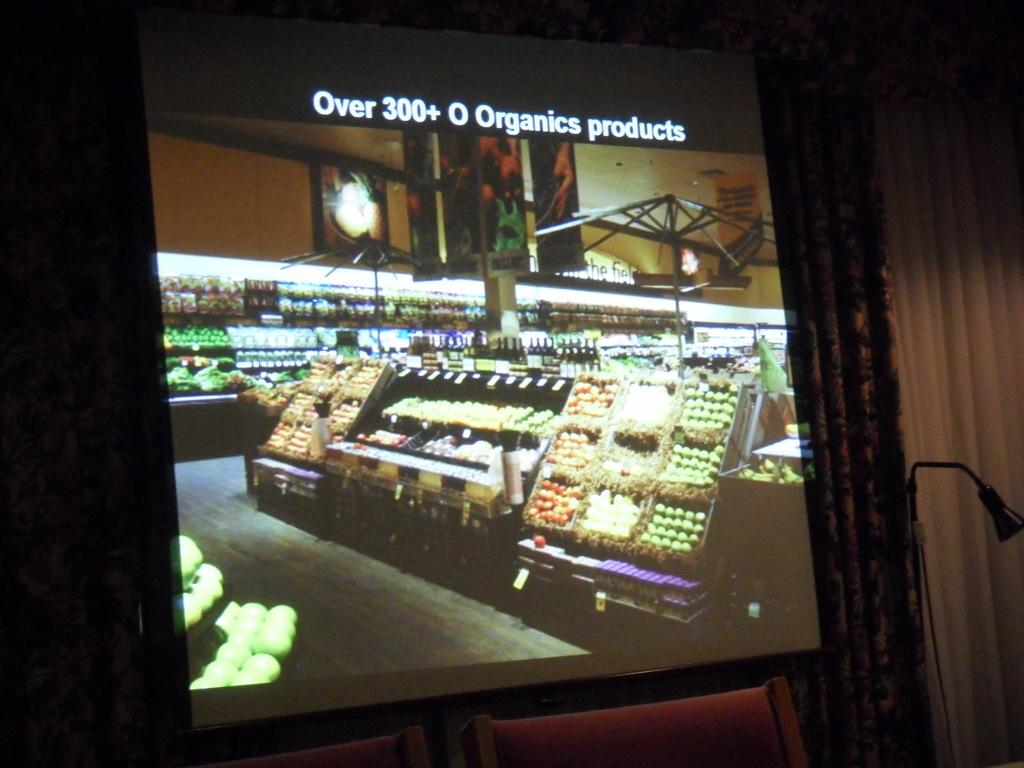<image>
Render a clear and concise summary of the photo. A screen showing an ad for a place that has over 300 organic products. 